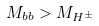Convert formula to latex. <formula><loc_0><loc_0><loc_500><loc_500>M _ { b b } > M _ { H ^ { \pm } }</formula> 